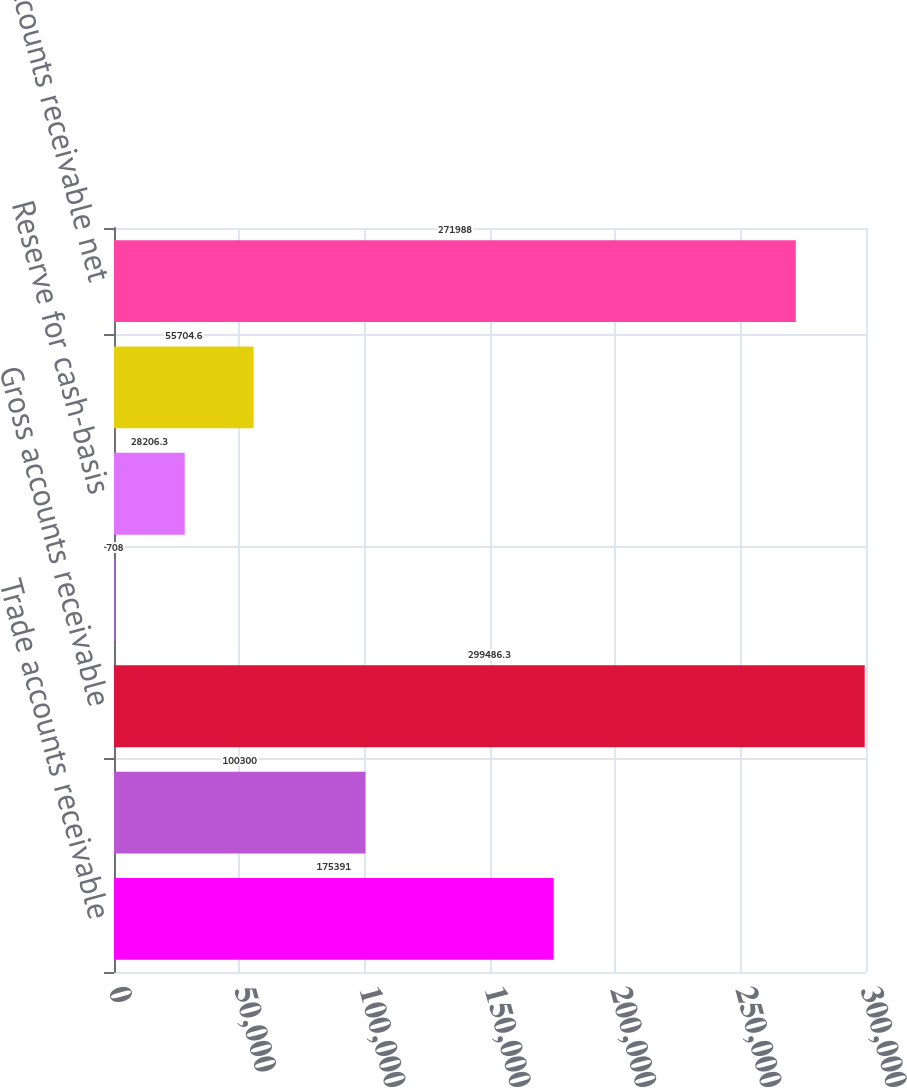<chart> <loc_0><loc_0><loc_500><loc_500><bar_chart><fcel>Trade accounts receivable<fcel>Unbilled accounts receivable<fcel>Gross accounts receivable<fcel>Allowance for doubtful<fcel>Reserve for cash-basis<fcel>Total accounts receivable<fcel>Accounts receivable net<nl><fcel>175391<fcel>100300<fcel>299486<fcel>708<fcel>28206.3<fcel>55704.6<fcel>271988<nl></chart> 